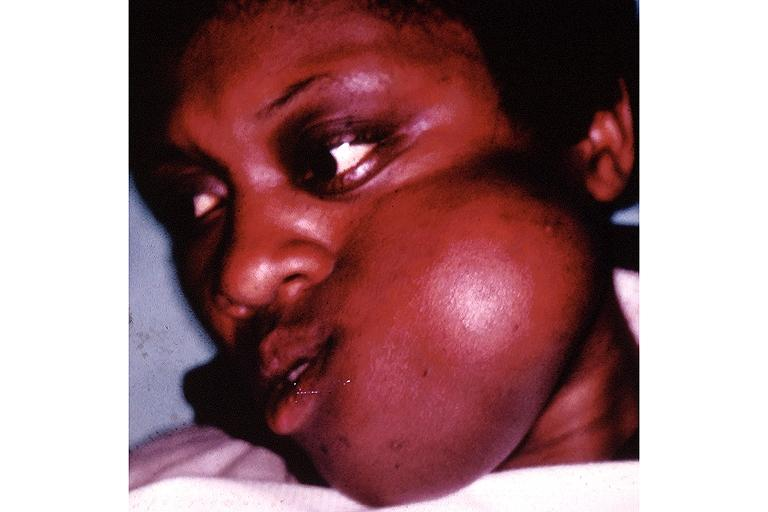what is present?
Answer the question using a single word or phrase. Oral 